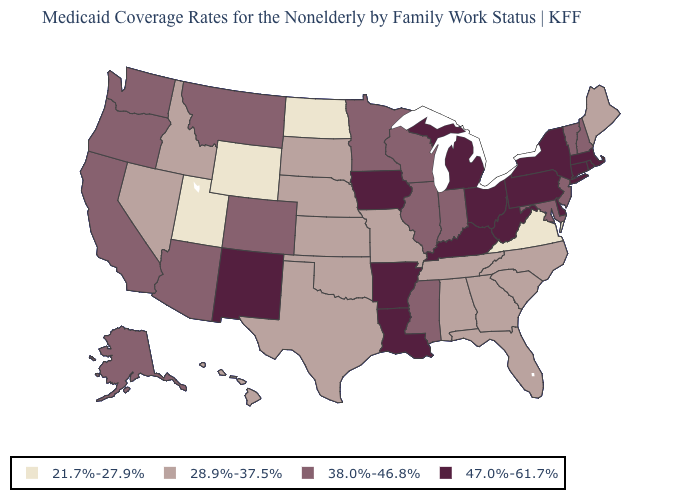Name the states that have a value in the range 47.0%-61.7%?
Be succinct. Arkansas, Connecticut, Delaware, Iowa, Kentucky, Louisiana, Massachusetts, Michigan, New Mexico, New York, Ohio, Pennsylvania, Rhode Island, West Virginia. Name the states that have a value in the range 28.9%-37.5%?
Keep it brief. Alabama, Florida, Georgia, Hawaii, Idaho, Kansas, Maine, Missouri, Nebraska, Nevada, North Carolina, Oklahoma, South Carolina, South Dakota, Tennessee, Texas. Which states have the lowest value in the West?
Keep it brief. Utah, Wyoming. Name the states that have a value in the range 28.9%-37.5%?
Answer briefly. Alabama, Florida, Georgia, Hawaii, Idaho, Kansas, Maine, Missouri, Nebraska, Nevada, North Carolina, Oklahoma, South Carolina, South Dakota, Tennessee, Texas. What is the value of Nevada?
Concise answer only. 28.9%-37.5%. What is the value of New Jersey?
Answer briefly. 38.0%-46.8%. Does Ohio have the highest value in the MidWest?
Be succinct. Yes. Name the states that have a value in the range 28.9%-37.5%?
Be succinct. Alabama, Florida, Georgia, Hawaii, Idaho, Kansas, Maine, Missouri, Nebraska, Nevada, North Carolina, Oklahoma, South Carolina, South Dakota, Tennessee, Texas. Does Oregon have a lower value than Wisconsin?
Short answer required. No. What is the value of Arizona?
Keep it brief. 38.0%-46.8%. Among the states that border Illinois , which have the highest value?
Be succinct. Iowa, Kentucky. Name the states that have a value in the range 38.0%-46.8%?
Concise answer only. Alaska, Arizona, California, Colorado, Illinois, Indiana, Maryland, Minnesota, Mississippi, Montana, New Hampshire, New Jersey, Oregon, Vermont, Washington, Wisconsin. Which states have the lowest value in the Northeast?
Keep it brief. Maine. What is the highest value in states that border Minnesota?
Quick response, please. 47.0%-61.7%. What is the value of Michigan?
Quick response, please. 47.0%-61.7%. 